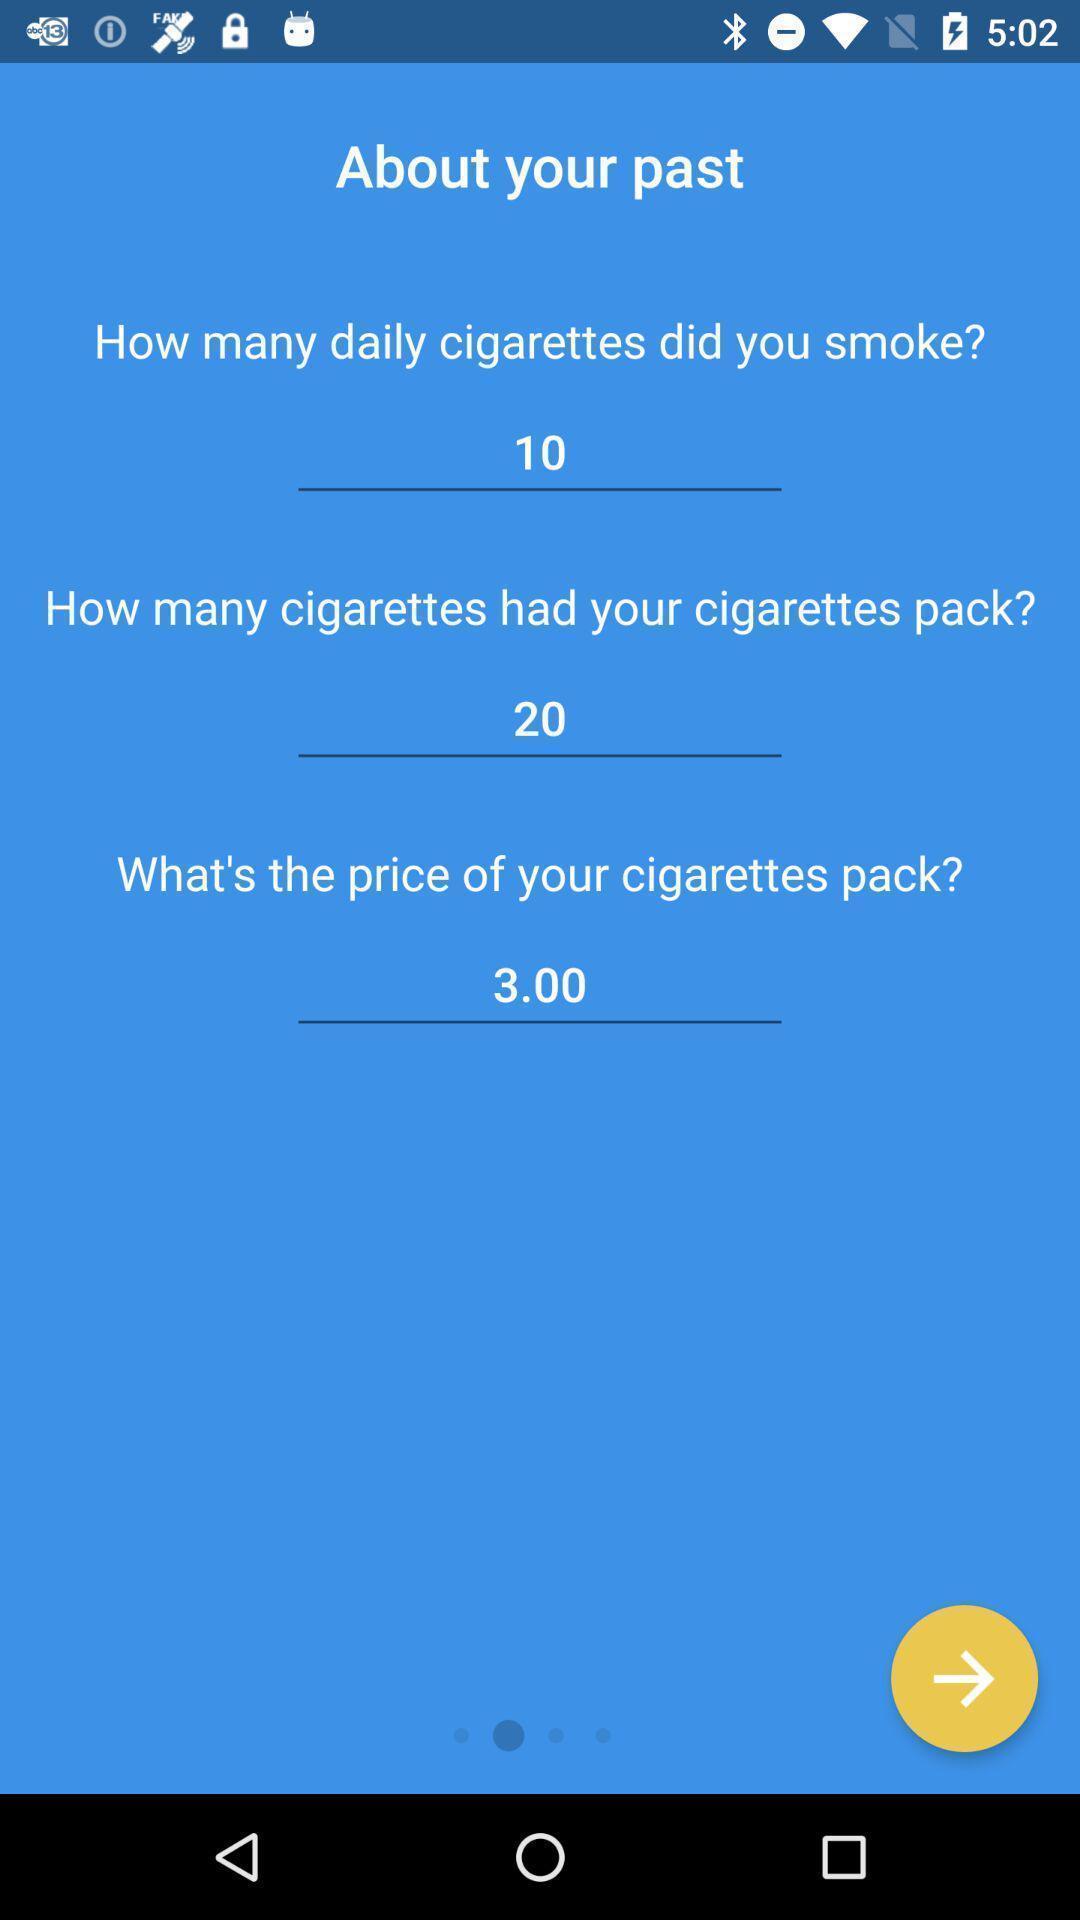Please provide a description for this image. Page with list of questions on an app. 